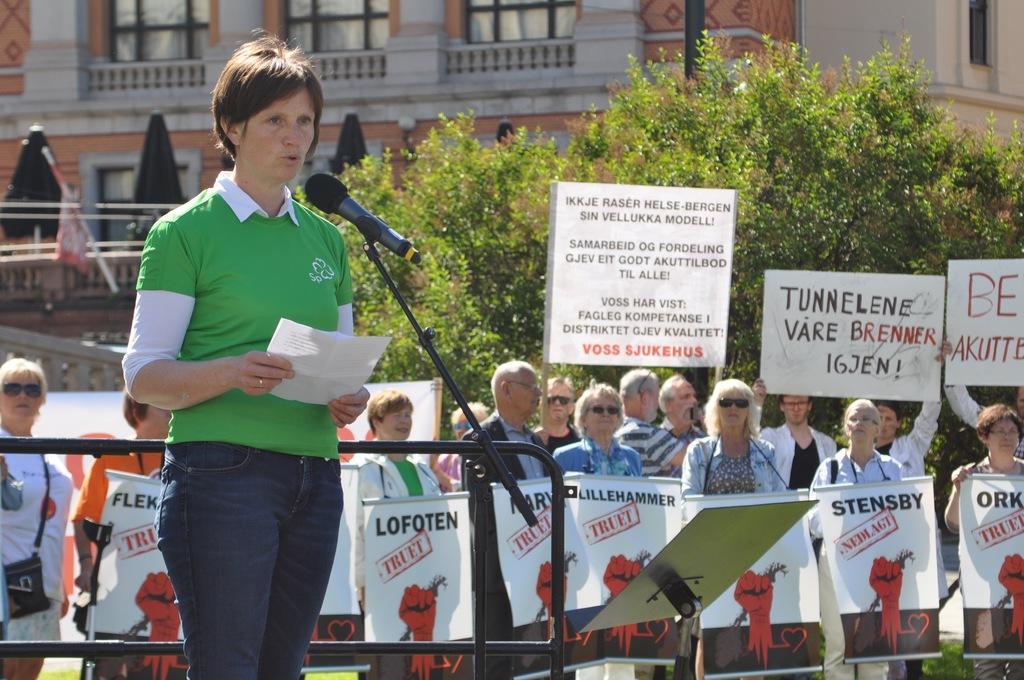Can you describe this image briefly? In this image I see number of people in which this woman is standing in front of a mic and I see that she is holding a paper in her hands and in the background I see that all of them are holding boards and banners in their hands and there is something written on them and I see the plants and I see a building over here and I see the black pole over here. 